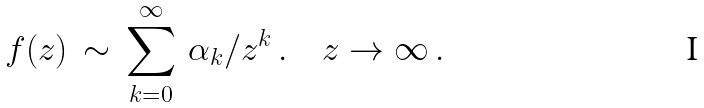<formula> <loc_0><loc_0><loc_500><loc_500>f ( z ) \, \sim \, \sum _ { k = 0 } ^ { \infty } \, \alpha _ { k } / z ^ { k } \, . \quad z \to \infty \, .</formula> 